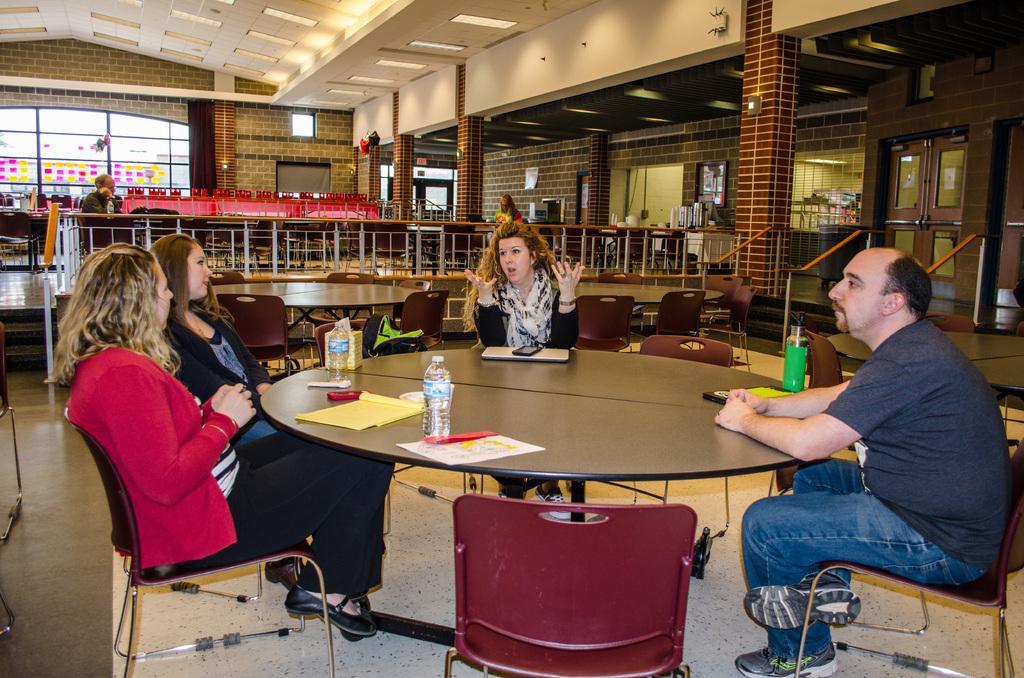Describe this image in one or two sentences. In this picture we can see three women sitting on the chair and a man wearing blue color t-shirt and jeans sitting on the chair. In front round table there is a water bottles and yellow color paper. Behind we can see a metal railing and a brick wall. Beside there is big glass window. 